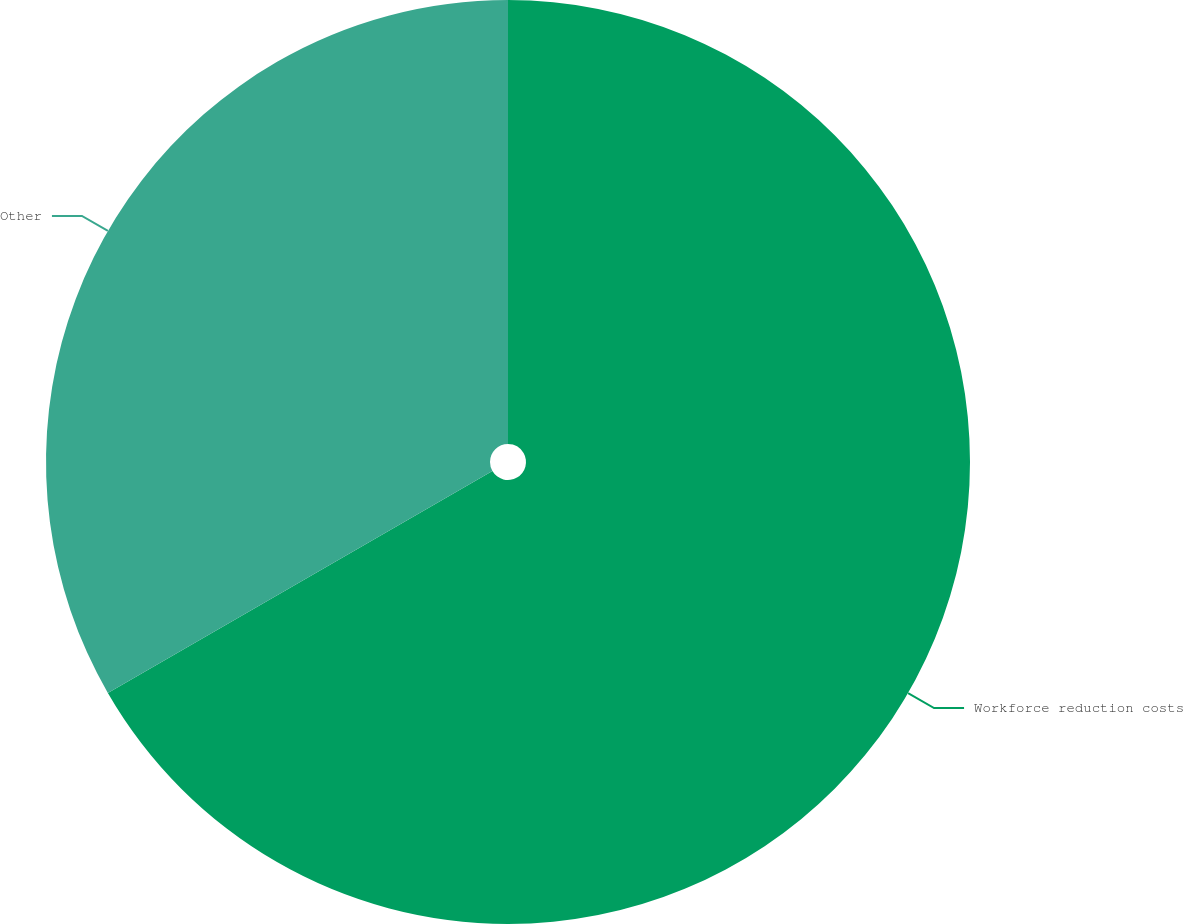Convert chart to OTSL. <chart><loc_0><loc_0><loc_500><loc_500><pie_chart><fcel>Workforce reduction costs<fcel>Other<nl><fcel>66.67%<fcel>33.33%<nl></chart> 